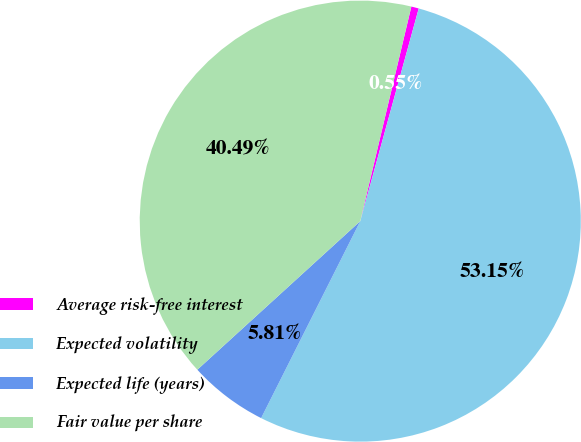Convert chart to OTSL. <chart><loc_0><loc_0><loc_500><loc_500><pie_chart><fcel>Average risk-free interest<fcel>Expected volatility<fcel>Expected life (years)<fcel>Fair value per share<nl><fcel>0.55%<fcel>53.15%<fcel>5.81%<fcel>40.49%<nl></chart> 